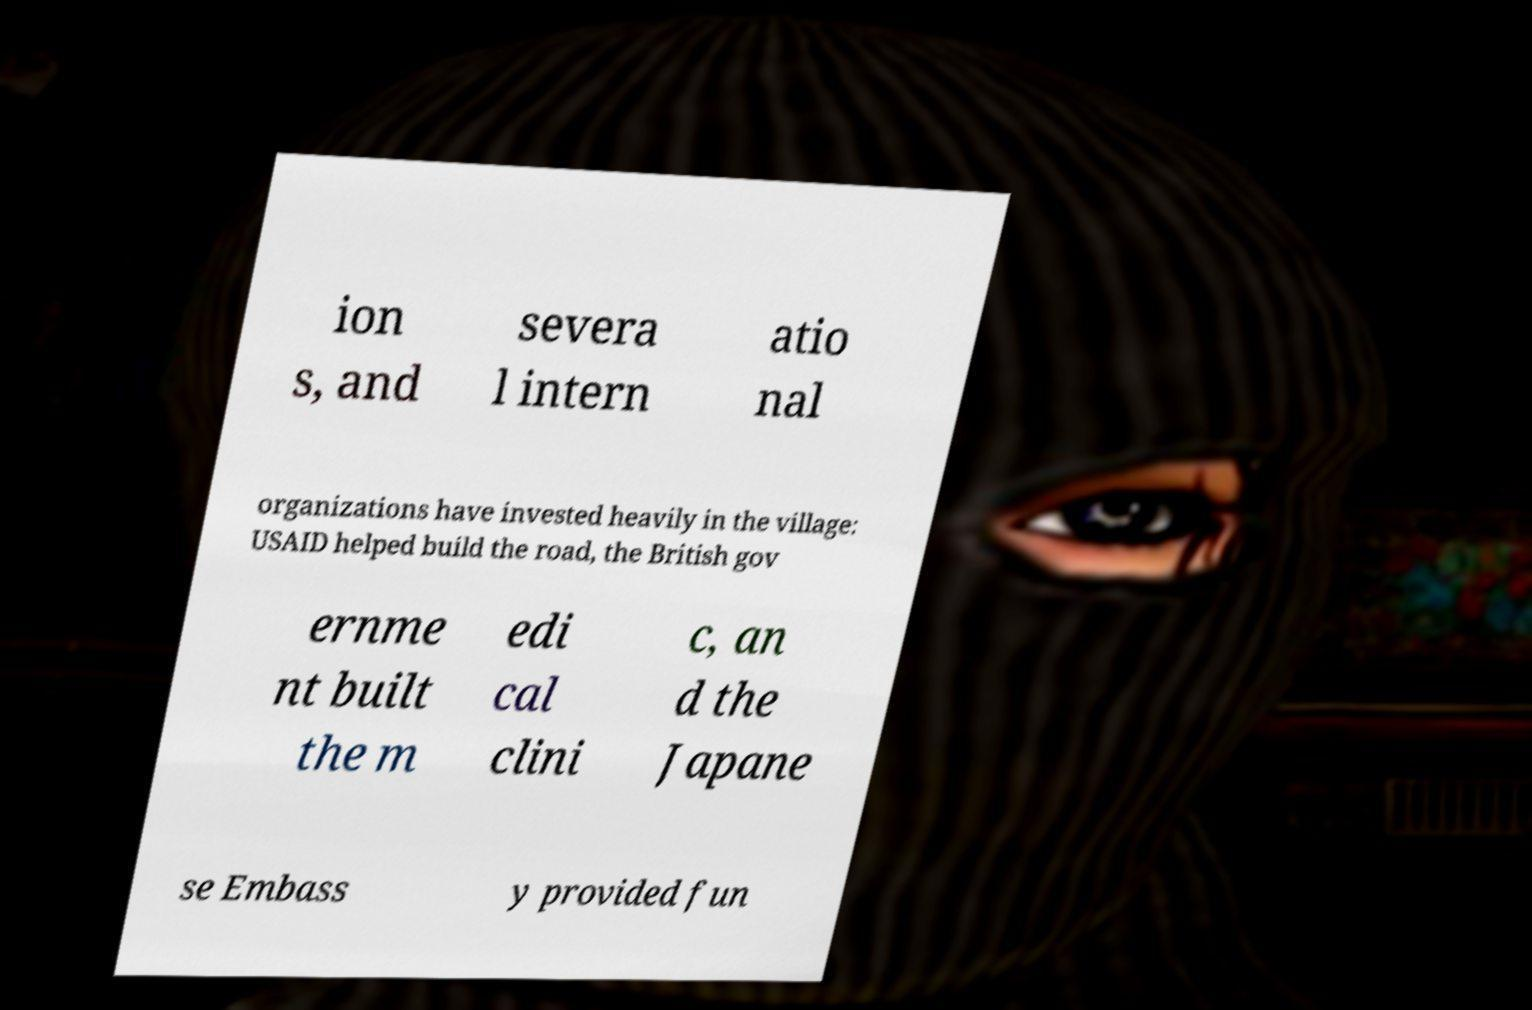Could you extract and type out the text from this image? ion s, and severa l intern atio nal organizations have invested heavily in the village: USAID helped build the road, the British gov ernme nt built the m edi cal clini c, an d the Japane se Embass y provided fun 